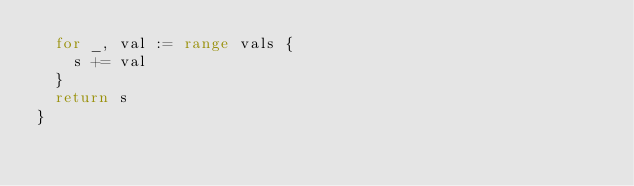<code> <loc_0><loc_0><loc_500><loc_500><_Go_>	for _, val := range vals {
		s += val
	}
	return s
}
</code> 